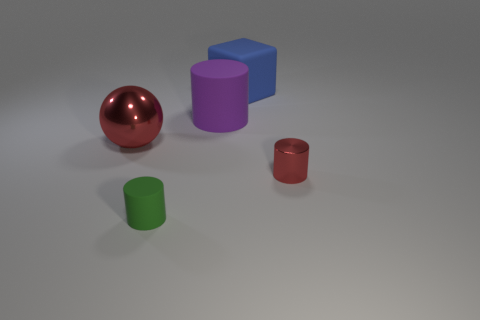The small green rubber thing has what shape?
Your answer should be compact. Cylinder. What is the shape of the big object that is to the left of the small object that is in front of the small red metal thing?
Provide a short and direct response. Sphere. Is the small thing to the left of the large matte block made of the same material as the blue cube?
Give a very brief answer. Yes. What number of brown things are big rubber objects or big matte cylinders?
Offer a terse response. 0. Is there another rubber cylinder of the same color as the big cylinder?
Provide a short and direct response. No. Is there a green thing made of the same material as the big red object?
Offer a terse response. No. What is the shape of the thing that is both right of the large purple rubber cylinder and on the left side of the red metallic cylinder?
Provide a short and direct response. Cube. How many tiny objects are green spheres or purple rubber things?
Provide a short and direct response. 0. What is the tiny red cylinder made of?
Make the answer very short. Metal. How many other things are there of the same shape as the small red thing?
Make the answer very short. 2. 